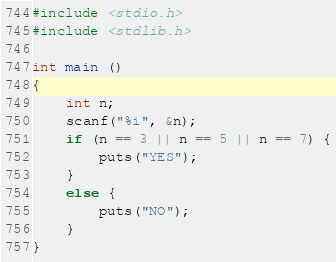Convert code to text. <code><loc_0><loc_0><loc_500><loc_500><_C_>#include <stdio.h>
#include <stdlib.h>

int main ()
{
    int n;
    scanf("%i", &n);
    if (n == 3 || n == 5 || n == 7) {
        puts("YES");
    }
    else {
        puts("NO");
    }
}</code> 